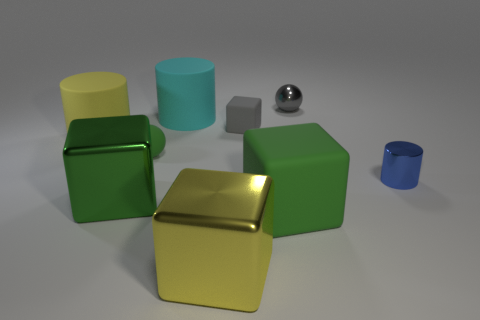Subtract 1 cubes. How many cubes are left? 3 Add 1 small gray rubber cubes. How many objects exist? 10 Subtract all red blocks. Subtract all blue balls. How many blocks are left? 4 Subtract all cylinders. How many objects are left? 6 Subtract all small red shiny spheres. Subtract all yellow rubber things. How many objects are left? 8 Add 7 big rubber cylinders. How many big rubber cylinders are left? 9 Add 4 small gray cubes. How many small gray cubes exist? 5 Subtract 2 green blocks. How many objects are left? 7 